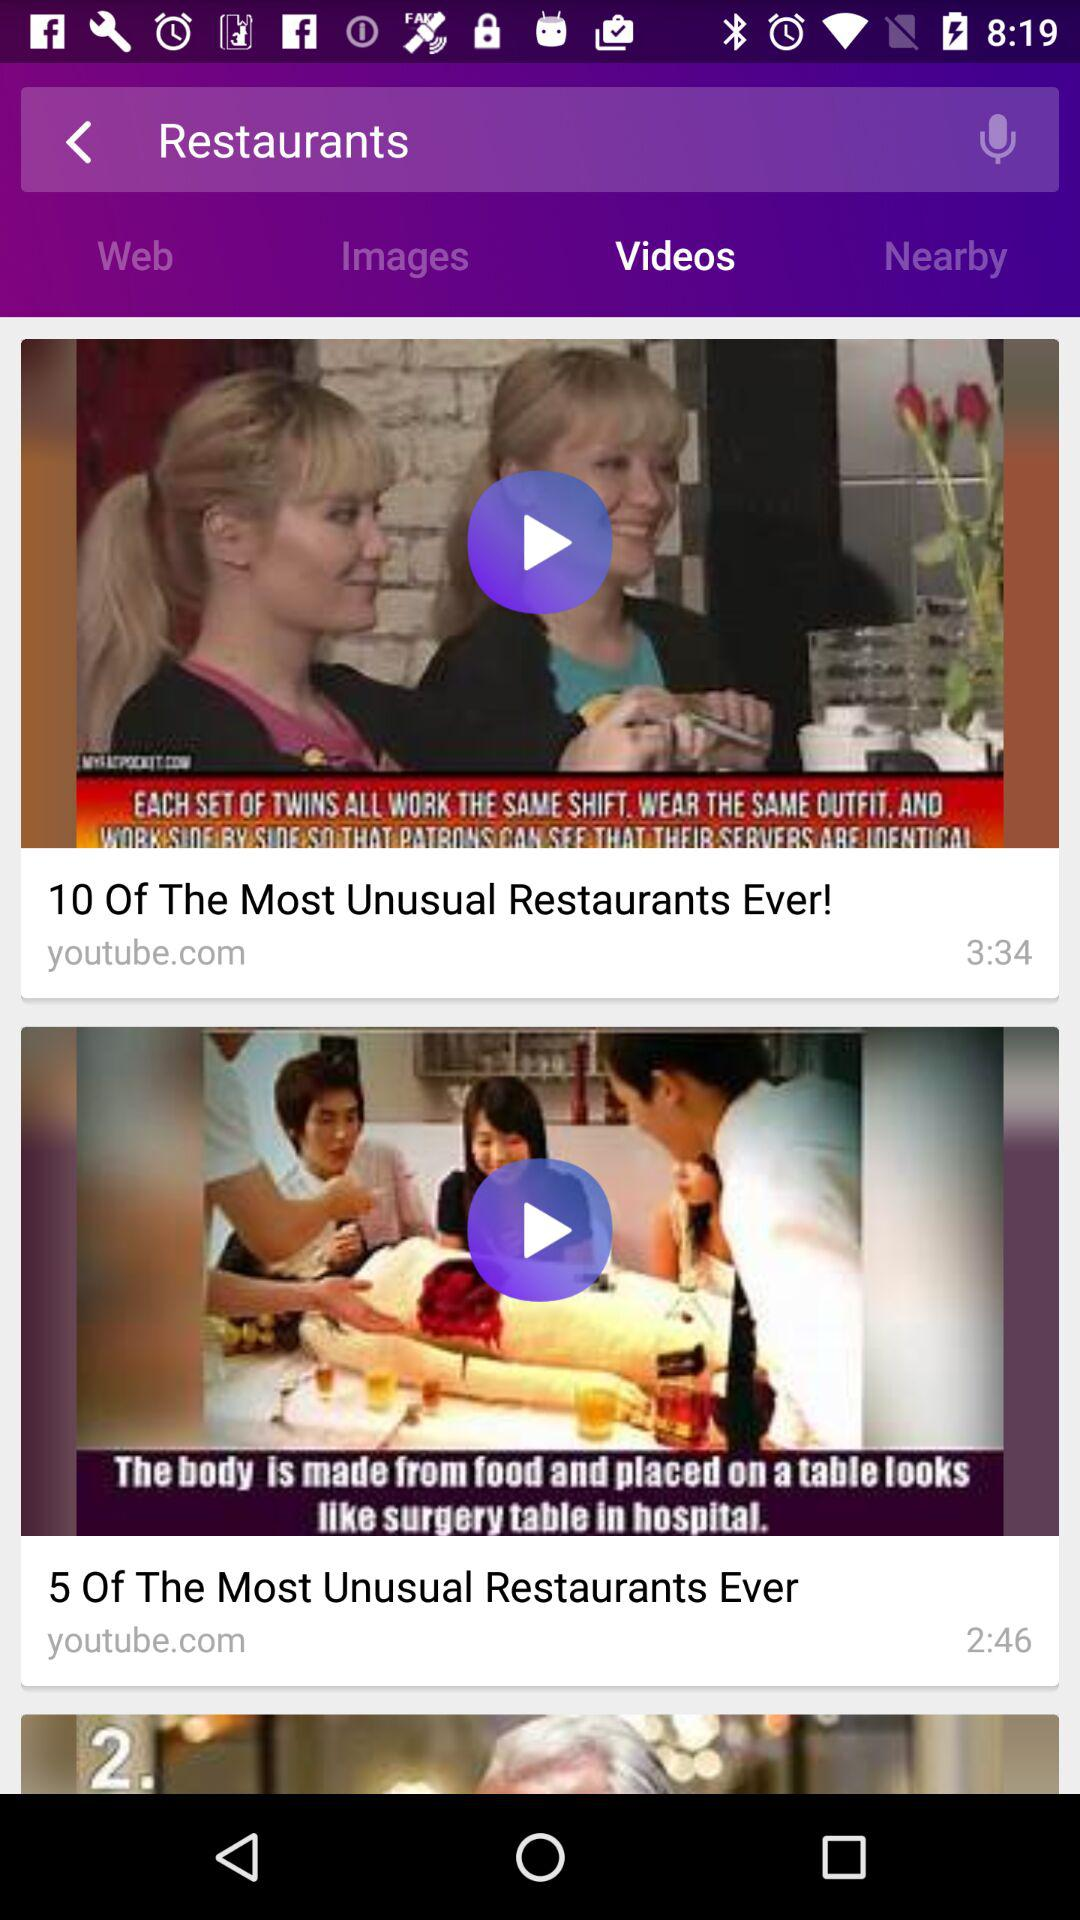What is the time duration of the video "5 Of The Most Unusual Restaurants Ever"? The time duration of the video "5 Of The Most Unusual Restaurants Ever" is 2 minutes 46 seconds. 